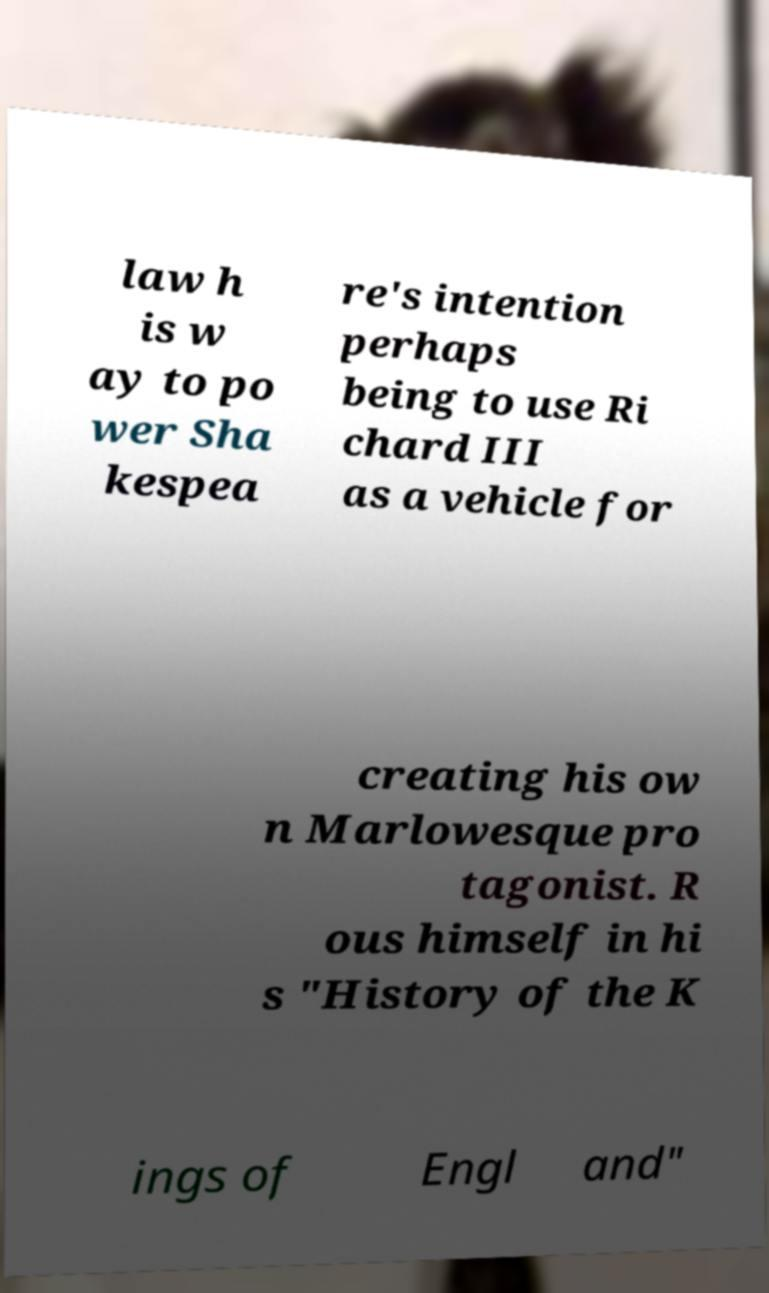I need the written content from this picture converted into text. Can you do that? law h is w ay to po wer Sha kespea re's intention perhaps being to use Ri chard III as a vehicle for creating his ow n Marlowesque pro tagonist. R ous himself in hi s "History of the K ings of Engl and" 